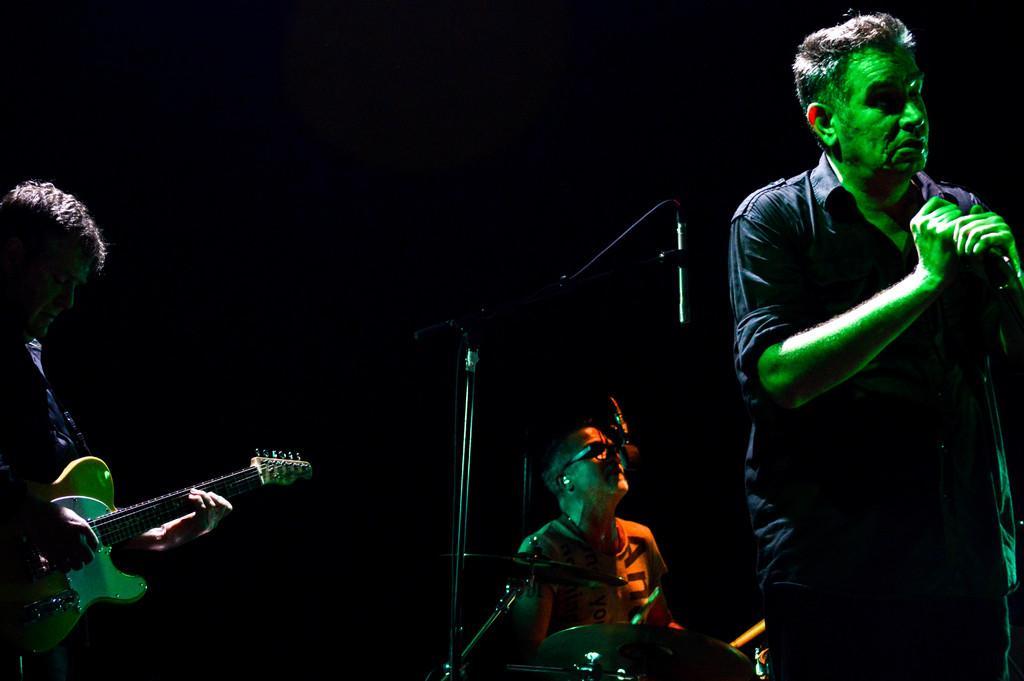Describe this image in one or two sentences. In the left, a person is standing and playing a guitar. In the middle bottom, a person is sitting and playing musical instruments in front of the mike. On the right , a person standing and singing a song. The background is dark in color. It seems as if the image is taken in a concert. 